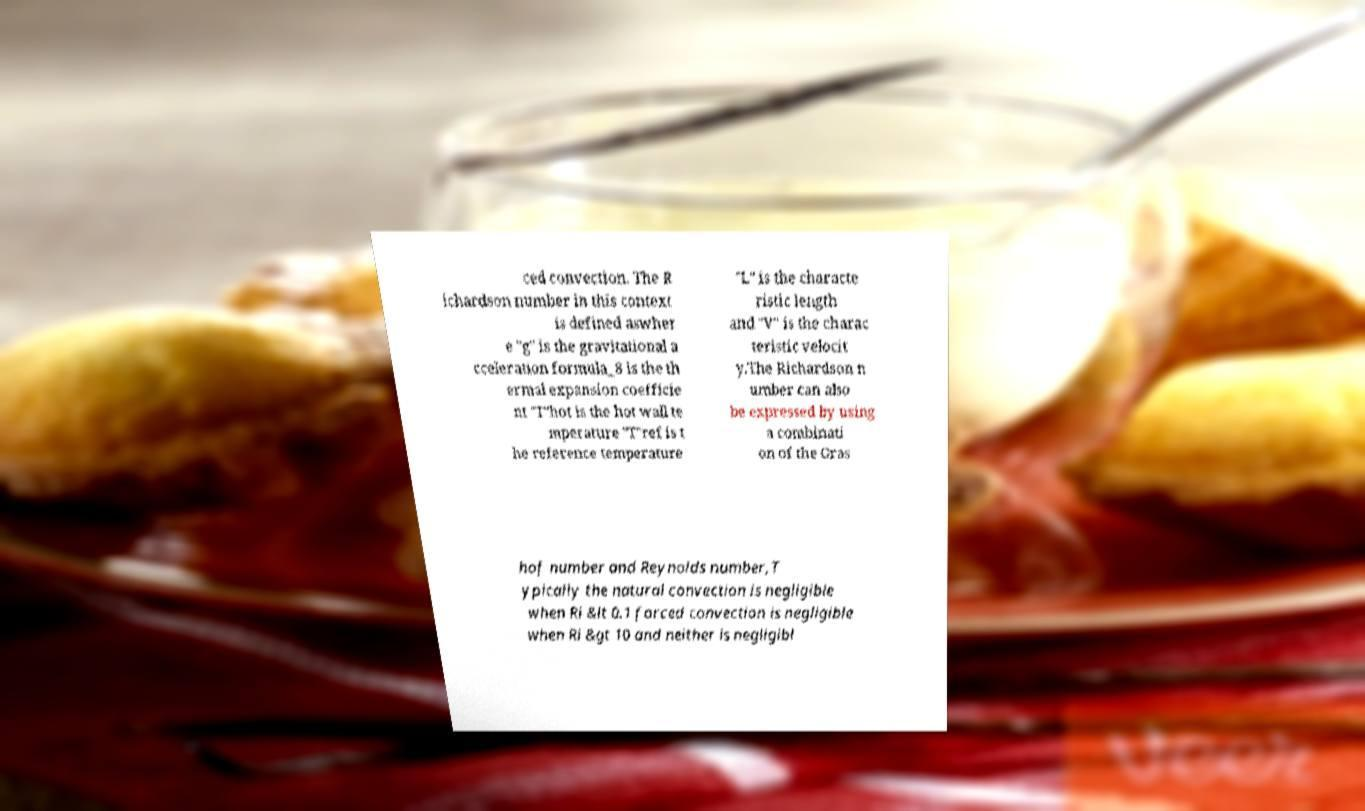Can you read and provide the text displayed in the image?This photo seems to have some interesting text. Can you extract and type it out for me? ced convection. The R ichardson number in this context is defined aswher e "g" is the gravitational a cceleration formula_8 is the th ermal expansion coefficie nt "T"hot is the hot wall te mperature "T"ref is t he reference temperature "L" is the characte ristic length and "V" is the charac teristic velocit y.The Richardson n umber can also be expressed by using a combinati on of the Gras hof number and Reynolds number,T ypically the natural convection is negligible when Ri &lt 0.1 forced convection is negligible when Ri &gt 10 and neither is negligibl 